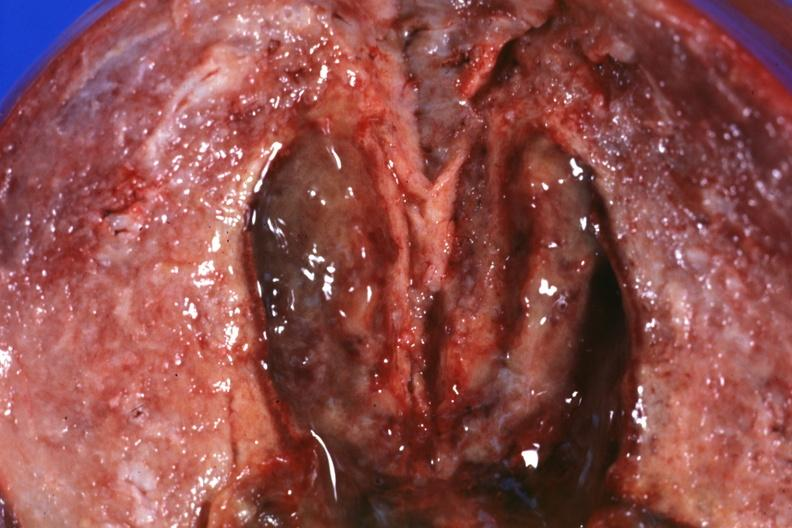how many hypertension does this image show close-up view of 5 weeks post section and brain hemorrhage?
Answer the question using a single word or phrase. 29yobf 